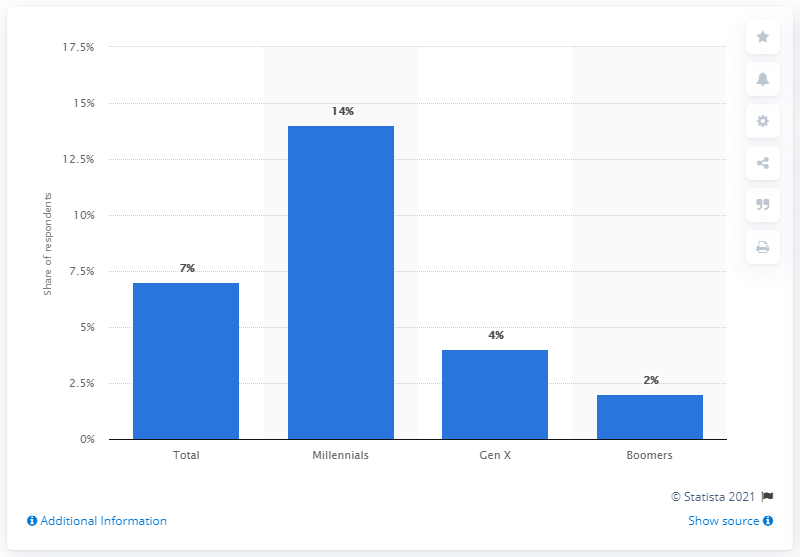Indicate a few pertinent items in this graphic. As of January 2017, 14% of Millennials subscribed to online video or music subscriptions also had a PlayStation Vue subscription. 